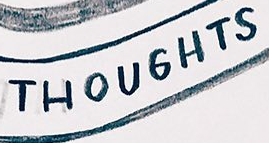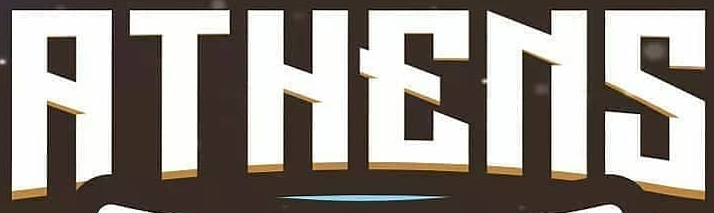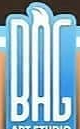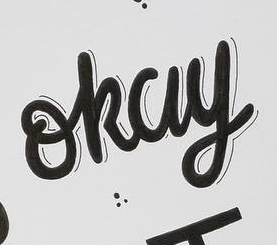Transcribe the words shown in these images in order, separated by a semicolon. THOUGHTS; RTHENS; BAG; okay 